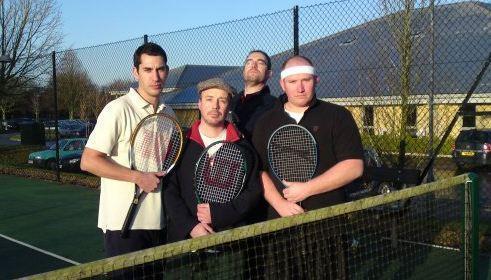How many people are in the photo?
Give a very brief answer. 4. How many tennis rackets are in the photo?
Give a very brief answer. 3. 